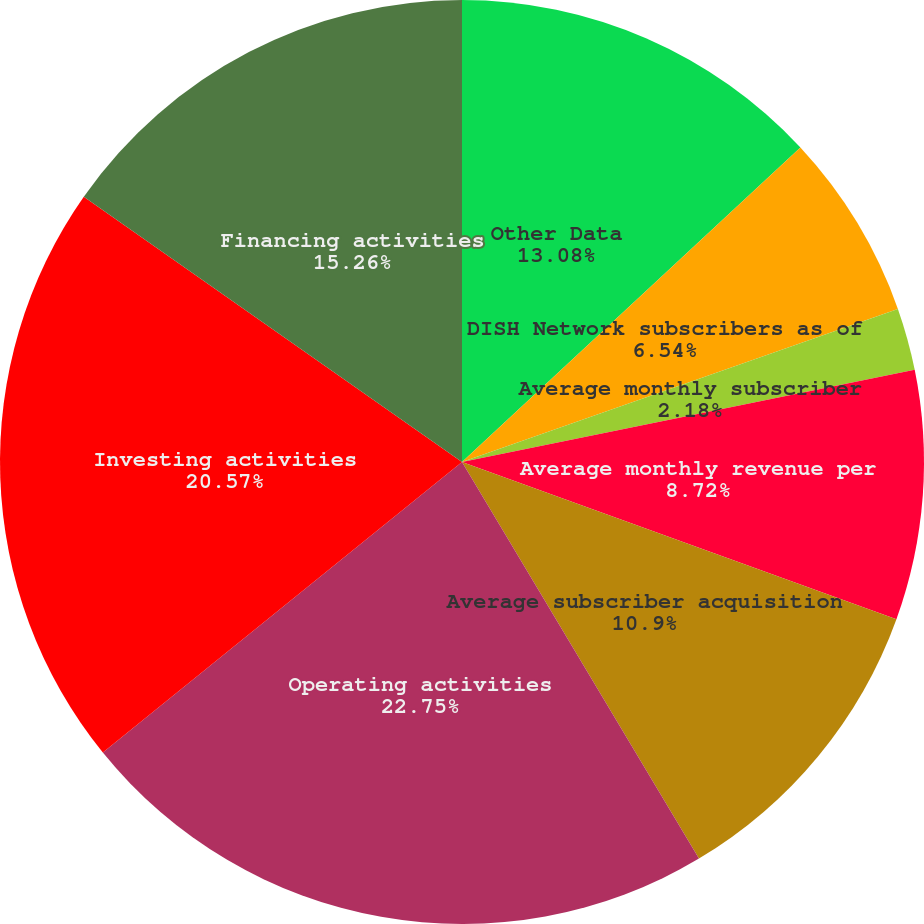Convert chart. <chart><loc_0><loc_0><loc_500><loc_500><pie_chart><fcel>Other Data<fcel>DISH Network subscribers as of<fcel>DISH Network subscriber<fcel>Average monthly subscriber<fcel>Average monthly revenue per<fcel>Average subscriber acquisition<fcel>Operating activities<fcel>Investing activities<fcel>Financing activities<nl><fcel>13.08%<fcel>6.54%<fcel>0.0%<fcel>2.18%<fcel>8.72%<fcel>10.9%<fcel>22.74%<fcel>20.56%<fcel>15.26%<nl></chart> 